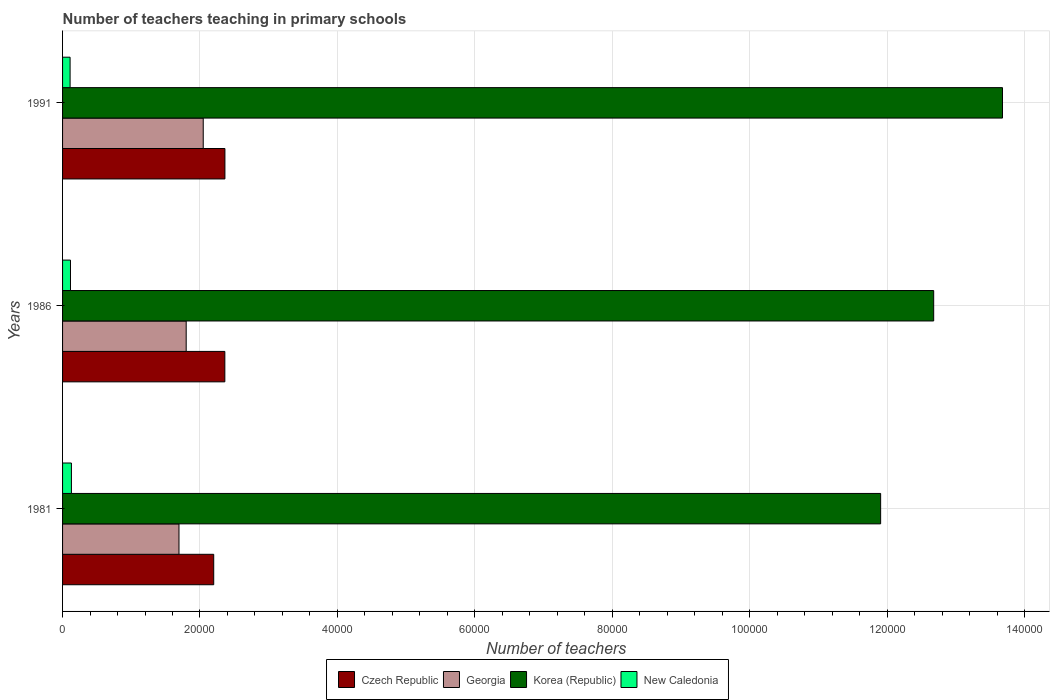How many groups of bars are there?
Your answer should be compact. 3. Are the number of bars on each tick of the Y-axis equal?
Provide a short and direct response. Yes. How many bars are there on the 2nd tick from the top?
Your answer should be very brief. 4. What is the label of the 3rd group of bars from the top?
Offer a terse response. 1981. In how many cases, is the number of bars for a given year not equal to the number of legend labels?
Make the answer very short. 0. What is the number of teachers teaching in primary schools in Czech Republic in 1986?
Offer a terse response. 2.36e+04. Across all years, what is the maximum number of teachers teaching in primary schools in New Caledonia?
Offer a very short reply. 1288. Across all years, what is the minimum number of teachers teaching in primary schools in Georgia?
Ensure brevity in your answer.  1.69e+04. In which year was the number of teachers teaching in primary schools in Korea (Republic) minimum?
Offer a very short reply. 1981. What is the total number of teachers teaching in primary schools in Czech Republic in the graph?
Your response must be concise. 6.92e+04. What is the difference between the number of teachers teaching in primary schools in Georgia in 1981 and that in 1986?
Keep it short and to the point. -1048. What is the difference between the number of teachers teaching in primary schools in Czech Republic in 1981 and the number of teachers teaching in primary schools in New Caledonia in 1986?
Offer a terse response. 2.08e+04. What is the average number of teachers teaching in primary schools in New Caledonia per year?
Your answer should be compact. 1179. In the year 1991, what is the difference between the number of teachers teaching in primary schools in Czech Republic and number of teachers teaching in primary schools in Korea (Republic)?
Keep it short and to the point. -1.13e+05. What is the ratio of the number of teachers teaching in primary schools in Korea (Republic) in 1981 to that in 1986?
Your response must be concise. 0.94. What is the difference between the highest and the second highest number of teachers teaching in primary schools in Korea (Republic)?
Give a very brief answer. 1.00e+04. What is the difference between the highest and the lowest number of teachers teaching in primary schools in Georgia?
Your response must be concise. 3529. In how many years, is the number of teachers teaching in primary schools in Czech Republic greater than the average number of teachers teaching in primary schools in Czech Republic taken over all years?
Your answer should be very brief. 2. Is the sum of the number of teachers teaching in primary schools in New Caledonia in 1981 and 1991 greater than the maximum number of teachers teaching in primary schools in Georgia across all years?
Make the answer very short. No. Is it the case that in every year, the sum of the number of teachers teaching in primary schools in Czech Republic and number of teachers teaching in primary schools in New Caledonia is greater than the sum of number of teachers teaching in primary schools in Korea (Republic) and number of teachers teaching in primary schools in Georgia?
Your answer should be very brief. No. What does the 4th bar from the bottom in 1981 represents?
Your response must be concise. New Caledonia. Is it the case that in every year, the sum of the number of teachers teaching in primary schools in Georgia and number of teachers teaching in primary schools in New Caledonia is greater than the number of teachers teaching in primary schools in Korea (Republic)?
Your answer should be very brief. No. How many bars are there?
Make the answer very short. 12. How many years are there in the graph?
Your response must be concise. 3. What is the difference between two consecutive major ticks on the X-axis?
Ensure brevity in your answer.  2.00e+04. Does the graph contain any zero values?
Make the answer very short. No. Does the graph contain grids?
Provide a succinct answer. Yes. What is the title of the graph?
Your answer should be very brief. Number of teachers teaching in primary schools. What is the label or title of the X-axis?
Your answer should be very brief. Number of teachers. What is the Number of teachers in Czech Republic in 1981?
Offer a very short reply. 2.20e+04. What is the Number of teachers of Georgia in 1981?
Your response must be concise. 1.69e+04. What is the Number of teachers of Korea (Republic) in 1981?
Your answer should be very brief. 1.19e+05. What is the Number of teachers in New Caledonia in 1981?
Offer a terse response. 1288. What is the Number of teachers of Czech Republic in 1986?
Your response must be concise. 2.36e+04. What is the Number of teachers of Georgia in 1986?
Your answer should be very brief. 1.80e+04. What is the Number of teachers of Korea (Republic) in 1986?
Your answer should be very brief. 1.27e+05. What is the Number of teachers in New Caledonia in 1986?
Make the answer very short. 1153. What is the Number of teachers of Czech Republic in 1991?
Provide a succinct answer. 2.36e+04. What is the Number of teachers of Georgia in 1991?
Ensure brevity in your answer.  2.05e+04. What is the Number of teachers of Korea (Republic) in 1991?
Provide a succinct answer. 1.37e+05. What is the Number of teachers in New Caledonia in 1991?
Provide a succinct answer. 1096. Across all years, what is the maximum Number of teachers of Czech Republic?
Provide a succinct answer. 2.36e+04. Across all years, what is the maximum Number of teachers in Georgia?
Ensure brevity in your answer.  2.05e+04. Across all years, what is the maximum Number of teachers in Korea (Republic)?
Provide a short and direct response. 1.37e+05. Across all years, what is the maximum Number of teachers of New Caledonia?
Provide a short and direct response. 1288. Across all years, what is the minimum Number of teachers of Czech Republic?
Keep it short and to the point. 2.20e+04. Across all years, what is the minimum Number of teachers in Georgia?
Give a very brief answer. 1.69e+04. Across all years, what is the minimum Number of teachers in Korea (Republic)?
Your answer should be compact. 1.19e+05. Across all years, what is the minimum Number of teachers of New Caledonia?
Your response must be concise. 1096. What is the total Number of teachers in Czech Republic in the graph?
Provide a short and direct response. 6.92e+04. What is the total Number of teachers in Georgia in the graph?
Provide a succinct answer. 5.54e+04. What is the total Number of teachers of Korea (Republic) in the graph?
Offer a very short reply. 3.83e+05. What is the total Number of teachers of New Caledonia in the graph?
Your answer should be compact. 3537. What is the difference between the Number of teachers in Czech Republic in 1981 and that in 1986?
Ensure brevity in your answer.  -1619. What is the difference between the Number of teachers of Georgia in 1981 and that in 1986?
Offer a very short reply. -1048. What is the difference between the Number of teachers of Korea (Republic) in 1981 and that in 1986?
Provide a succinct answer. -7721. What is the difference between the Number of teachers of New Caledonia in 1981 and that in 1986?
Provide a succinct answer. 135. What is the difference between the Number of teachers in Czech Republic in 1981 and that in 1991?
Offer a terse response. -1631. What is the difference between the Number of teachers of Georgia in 1981 and that in 1991?
Keep it short and to the point. -3529. What is the difference between the Number of teachers in Korea (Republic) in 1981 and that in 1991?
Your answer should be compact. -1.77e+04. What is the difference between the Number of teachers of New Caledonia in 1981 and that in 1991?
Ensure brevity in your answer.  192. What is the difference between the Number of teachers in Czech Republic in 1986 and that in 1991?
Give a very brief answer. -12. What is the difference between the Number of teachers in Georgia in 1986 and that in 1991?
Provide a short and direct response. -2481. What is the difference between the Number of teachers in Korea (Republic) in 1986 and that in 1991?
Make the answer very short. -1.00e+04. What is the difference between the Number of teachers of Czech Republic in 1981 and the Number of teachers of Georgia in 1986?
Keep it short and to the point. 4007. What is the difference between the Number of teachers of Czech Republic in 1981 and the Number of teachers of Korea (Republic) in 1986?
Offer a terse response. -1.05e+05. What is the difference between the Number of teachers of Czech Republic in 1981 and the Number of teachers of New Caledonia in 1986?
Provide a succinct answer. 2.08e+04. What is the difference between the Number of teachers in Georgia in 1981 and the Number of teachers in Korea (Republic) in 1986?
Keep it short and to the point. -1.10e+05. What is the difference between the Number of teachers in Georgia in 1981 and the Number of teachers in New Caledonia in 1986?
Keep it short and to the point. 1.58e+04. What is the difference between the Number of teachers of Korea (Republic) in 1981 and the Number of teachers of New Caledonia in 1986?
Your answer should be very brief. 1.18e+05. What is the difference between the Number of teachers of Czech Republic in 1981 and the Number of teachers of Georgia in 1991?
Give a very brief answer. 1526. What is the difference between the Number of teachers of Czech Republic in 1981 and the Number of teachers of Korea (Republic) in 1991?
Make the answer very short. -1.15e+05. What is the difference between the Number of teachers in Czech Republic in 1981 and the Number of teachers in New Caledonia in 1991?
Give a very brief answer. 2.09e+04. What is the difference between the Number of teachers of Georgia in 1981 and the Number of teachers of Korea (Republic) in 1991?
Your answer should be compact. -1.20e+05. What is the difference between the Number of teachers in Georgia in 1981 and the Number of teachers in New Caledonia in 1991?
Give a very brief answer. 1.58e+04. What is the difference between the Number of teachers in Korea (Republic) in 1981 and the Number of teachers in New Caledonia in 1991?
Offer a very short reply. 1.18e+05. What is the difference between the Number of teachers of Czech Republic in 1986 and the Number of teachers of Georgia in 1991?
Provide a succinct answer. 3145. What is the difference between the Number of teachers in Czech Republic in 1986 and the Number of teachers in Korea (Republic) in 1991?
Ensure brevity in your answer.  -1.13e+05. What is the difference between the Number of teachers in Czech Republic in 1986 and the Number of teachers in New Caledonia in 1991?
Offer a very short reply. 2.25e+04. What is the difference between the Number of teachers of Georgia in 1986 and the Number of teachers of Korea (Republic) in 1991?
Your answer should be very brief. -1.19e+05. What is the difference between the Number of teachers of Georgia in 1986 and the Number of teachers of New Caledonia in 1991?
Offer a very short reply. 1.69e+04. What is the difference between the Number of teachers of Korea (Republic) in 1986 and the Number of teachers of New Caledonia in 1991?
Provide a succinct answer. 1.26e+05. What is the average Number of teachers of Czech Republic per year?
Offer a very short reply. 2.31e+04. What is the average Number of teachers of Georgia per year?
Offer a terse response. 1.85e+04. What is the average Number of teachers of Korea (Republic) per year?
Provide a succinct answer. 1.28e+05. What is the average Number of teachers of New Caledonia per year?
Offer a very short reply. 1179. In the year 1981, what is the difference between the Number of teachers in Czech Republic and Number of teachers in Georgia?
Make the answer very short. 5055. In the year 1981, what is the difference between the Number of teachers of Czech Republic and Number of teachers of Korea (Republic)?
Ensure brevity in your answer.  -9.71e+04. In the year 1981, what is the difference between the Number of teachers of Czech Republic and Number of teachers of New Caledonia?
Keep it short and to the point. 2.07e+04. In the year 1981, what is the difference between the Number of teachers in Georgia and Number of teachers in Korea (Republic)?
Offer a very short reply. -1.02e+05. In the year 1981, what is the difference between the Number of teachers in Georgia and Number of teachers in New Caledonia?
Offer a terse response. 1.57e+04. In the year 1981, what is the difference between the Number of teachers in Korea (Republic) and Number of teachers in New Caledonia?
Ensure brevity in your answer.  1.18e+05. In the year 1986, what is the difference between the Number of teachers in Czech Republic and Number of teachers in Georgia?
Provide a succinct answer. 5626. In the year 1986, what is the difference between the Number of teachers of Czech Republic and Number of teachers of Korea (Republic)?
Offer a terse response. -1.03e+05. In the year 1986, what is the difference between the Number of teachers of Czech Republic and Number of teachers of New Caledonia?
Provide a short and direct response. 2.25e+04. In the year 1986, what is the difference between the Number of teachers of Georgia and Number of teachers of Korea (Republic)?
Give a very brief answer. -1.09e+05. In the year 1986, what is the difference between the Number of teachers of Georgia and Number of teachers of New Caledonia?
Keep it short and to the point. 1.68e+04. In the year 1986, what is the difference between the Number of teachers of Korea (Republic) and Number of teachers of New Caledonia?
Offer a very short reply. 1.26e+05. In the year 1991, what is the difference between the Number of teachers in Czech Republic and Number of teachers in Georgia?
Keep it short and to the point. 3157. In the year 1991, what is the difference between the Number of teachers of Czech Republic and Number of teachers of Korea (Republic)?
Give a very brief answer. -1.13e+05. In the year 1991, what is the difference between the Number of teachers of Czech Republic and Number of teachers of New Caledonia?
Give a very brief answer. 2.25e+04. In the year 1991, what is the difference between the Number of teachers in Georgia and Number of teachers in Korea (Republic)?
Provide a succinct answer. -1.16e+05. In the year 1991, what is the difference between the Number of teachers in Georgia and Number of teachers in New Caledonia?
Keep it short and to the point. 1.94e+04. In the year 1991, what is the difference between the Number of teachers in Korea (Republic) and Number of teachers in New Caledonia?
Provide a short and direct response. 1.36e+05. What is the ratio of the Number of teachers of Czech Republic in 1981 to that in 1986?
Your answer should be very brief. 0.93. What is the ratio of the Number of teachers in Georgia in 1981 to that in 1986?
Your response must be concise. 0.94. What is the ratio of the Number of teachers of Korea (Republic) in 1981 to that in 1986?
Offer a very short reply. 0.94. What is the ratio of the Number of teachers of New Caledonia in 1981 to that in 1986?
Give a very brief answer. 1.12. What is the ratio of the Number of teachers of Czech Republic in 1981 to that in 1991?
Keep it short and to the point. 0.93. What is the ratio of the Number of teachers of Georgia in 1981 to that in 1991?
Offer a very short reply. 0.83. What is the ratio of the Number of teachers in Korea (Republic) in 1981 to that in 1991?
Offer a very short reply. 0.87. What is the ratio of the Number of teachers in New Caledonia in 1981 to that in 1991?
Your answer should be very brief. 1.18. What is the ratio of the Number of teachers of Georgia in 1986 to that in 1991?
Give a very brief answer. 0.88. What is the ratio of the Number of teachers in Korea (Republic) in 1986 to that in 1991?
Ensure brevity in your answer.  0.93. What is the ratio of the Number of teachers in New Caledonia in 1986 to that in 1991?
Ensure brevity in your answer.  1.05. What is the difference between the highest and the second highest Number of teachers of Georgia?
Your response must be concise. 2481. What is the difference between the highest and the second highest Number of teachers in Korea (Republic)?
Your response must be concise. 1.00e+04. What is the difference between the highest and the second highest Number of teachers of New Caledonia?
Ensure brevity in your answer.  135. What is the difference between the highest and the lowest Number of teachers of Czech Republic?
Make the answer very short. 1631. What is the difference between the highest and the lowest Number of teachers in Georgia?
Offer a terse response. 3529. What is the difference between the highest and the lowest Number of teachers in Korea (Republic)?
Your answer should be compact. 1.77e+04. What is the difference between the highest and the lowest Number of teachers in New Caledonia?
Give a very brief answer. 192. 